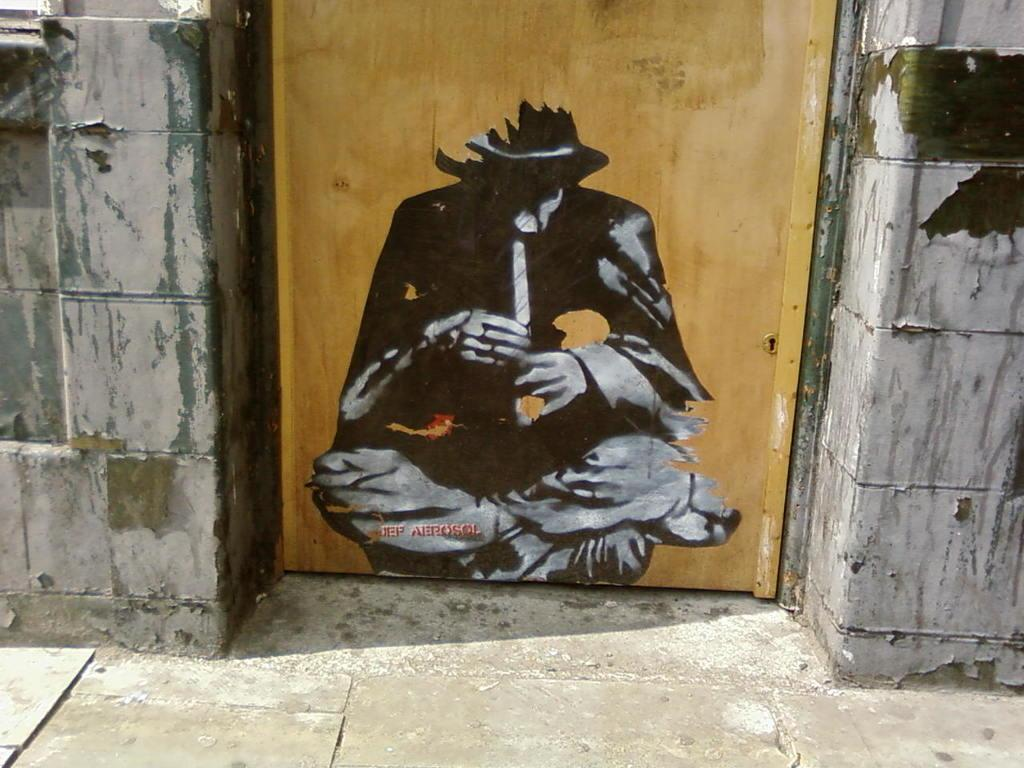What structure is the main subject of the image? There is a building in the image. Can you describe a specific feature of the building? There is a door at the center of the building. What is depicted on the door? There is a painting on the door. What type of feather can be seen on the airplane in the image? There is no airplane present in the image, so there cannot be any feathers associated with it. 